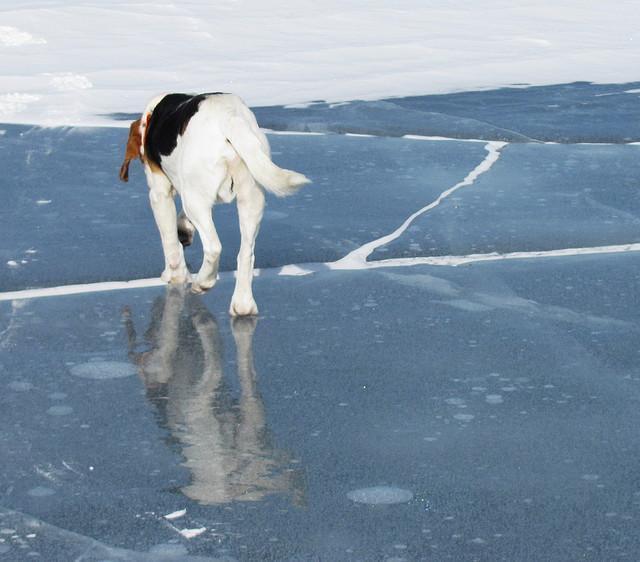How many dogs are there?
Give a very brief answer. 1. 